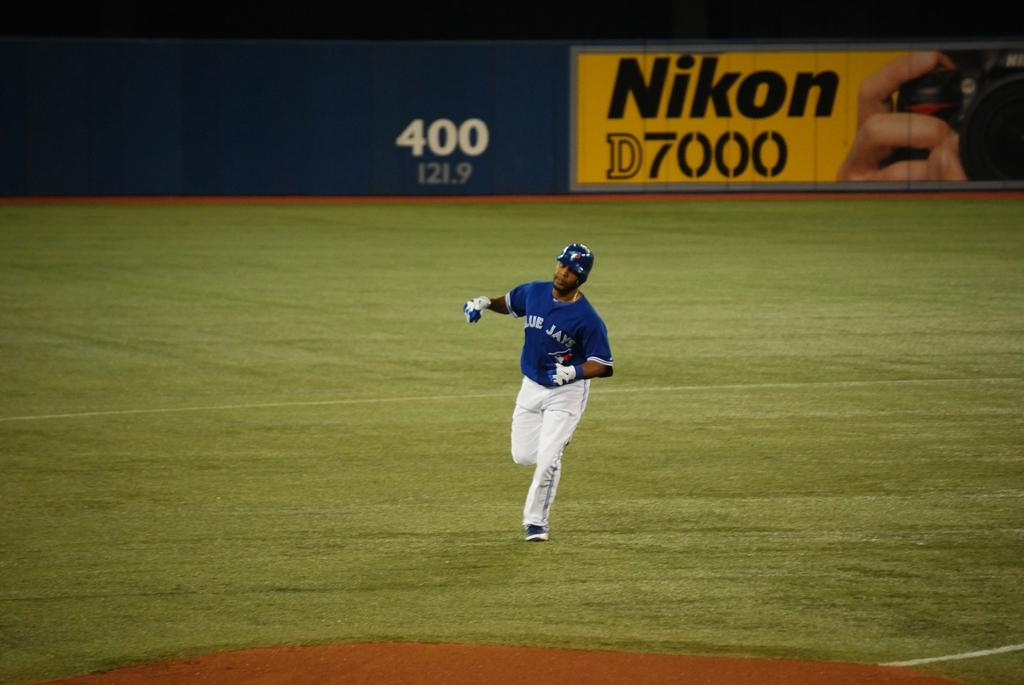Provide a one-sentence caption for the provided image. the Blue Jay player is in front of a Nikon D7000 board. 